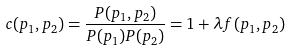<formula> <loc_0><loc_0><loc_500><loc_500>c ( p _ { 1 } , p _ { 2 } ) = \frac { P ( p _ { 1 } , p _ { 2 } ) } { P ( p _ { 1 } ) P ( p _ { 2 } ) } = 1 + \lambda f ( p _ { 1 } , p _ { 2 } )</formula> 